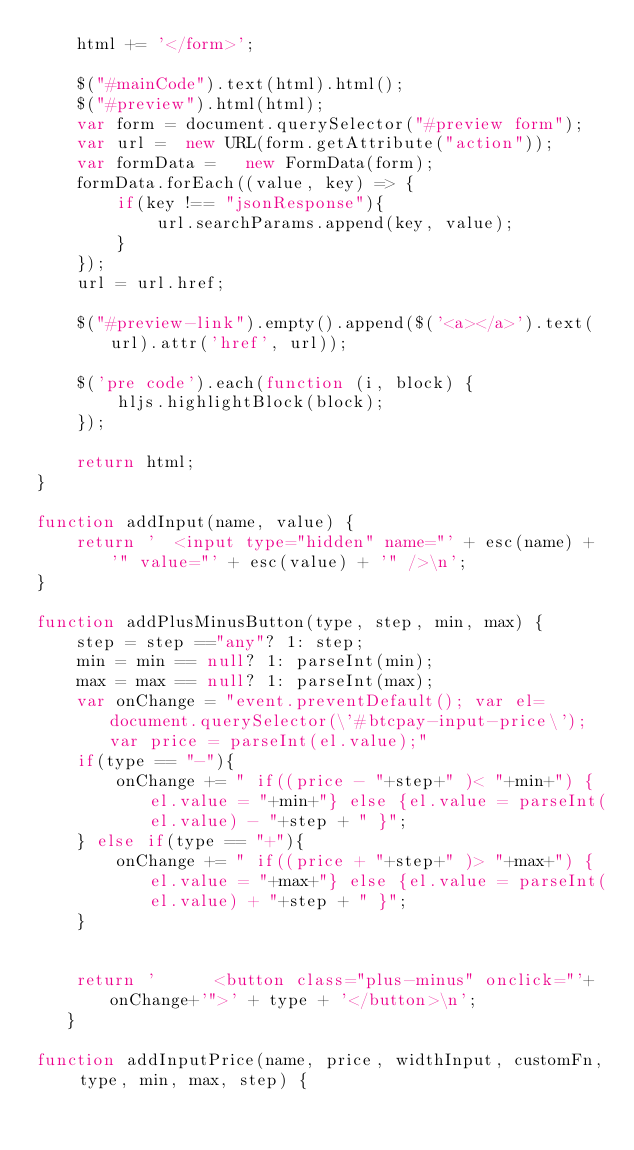<code> <loc_0><loc_0><loc_500><loc_500><_JavaScript_>    html += '</form>';

    $("#mainCode").text(html).html();
    $("#preview").html(html);
    var form = document.querySelector("#preview form");
    var url =  new URL(form.getAttribute("action"));
    var formData =   new FormData(form);
    formData.forEach((value, key) => {
        if(key !== "jsonResponse"){
            url.searchParams.append(key, value);
        }
    });
    url = url.href;
    
    $("#preview-link").empty().append($('<a></a>').text(url).attr('href', url));
    
    $('pre code').each(function (i, block) {
        hljs.highlightBlock(block);
    });

    return html;
}

function addInput(name, value) {
    return '  <input type="hidden" name="' + esc(name) + '" value="' + esc(value) + '" />\n';
}

function addPlusMinusButton(type, step, min, max) {
    step = step =="any"? 1: step;
    min = min == null? 1: parseInt(min);
    max = max == null? 1: parseInt(max);
    var onChange = "event.preventDefault(); var el=document.querySelector(\'#btcpay-input-price\'); var price = parseInt(el.value);"
    if(type == "-"){
        onChange += " if((price - "+step+" )< "+min+") { el.value = "+min+"} else {el.value = parseInt(el.value) - "+step + " }";
    } else if(type == "+"){
        onChange += " if((price + "+step+" )> "+max+") { el.value = "+max+"} else {el.value = parseInt(el.value) + "+step + " }";
    }
    
    
    return '      <button class="plus-minus" onclick="'+onChange+'">' + type + '</button>\n';
   }

function addInputPrice(name, price, widthInput, customFn, type, min, max, step) {</code> 